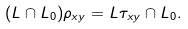Convert formula to latex. <formula><loc_0><loc_0><loc_500><loc_500>( L \cap L _ { 0 } ) \rho _ { x y } = L \tau _ { x y } \cap L _ { 0 } .</formula> 